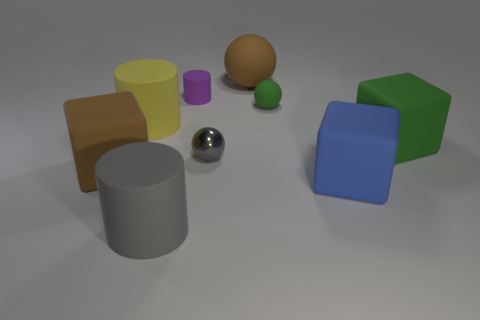Subtract all spheres. How many objects are left? 6 Subtract 0 red cylinders. How many objects are left? 9 Subtract all metal things. Subtract all big blue rubber cubes. How many objects are left? 7 Add 7 large rubber blocks. How many large rubber blocks are left? 10 Add 2 big brown matte cubes. How many big brown matte cubes exist? 3 